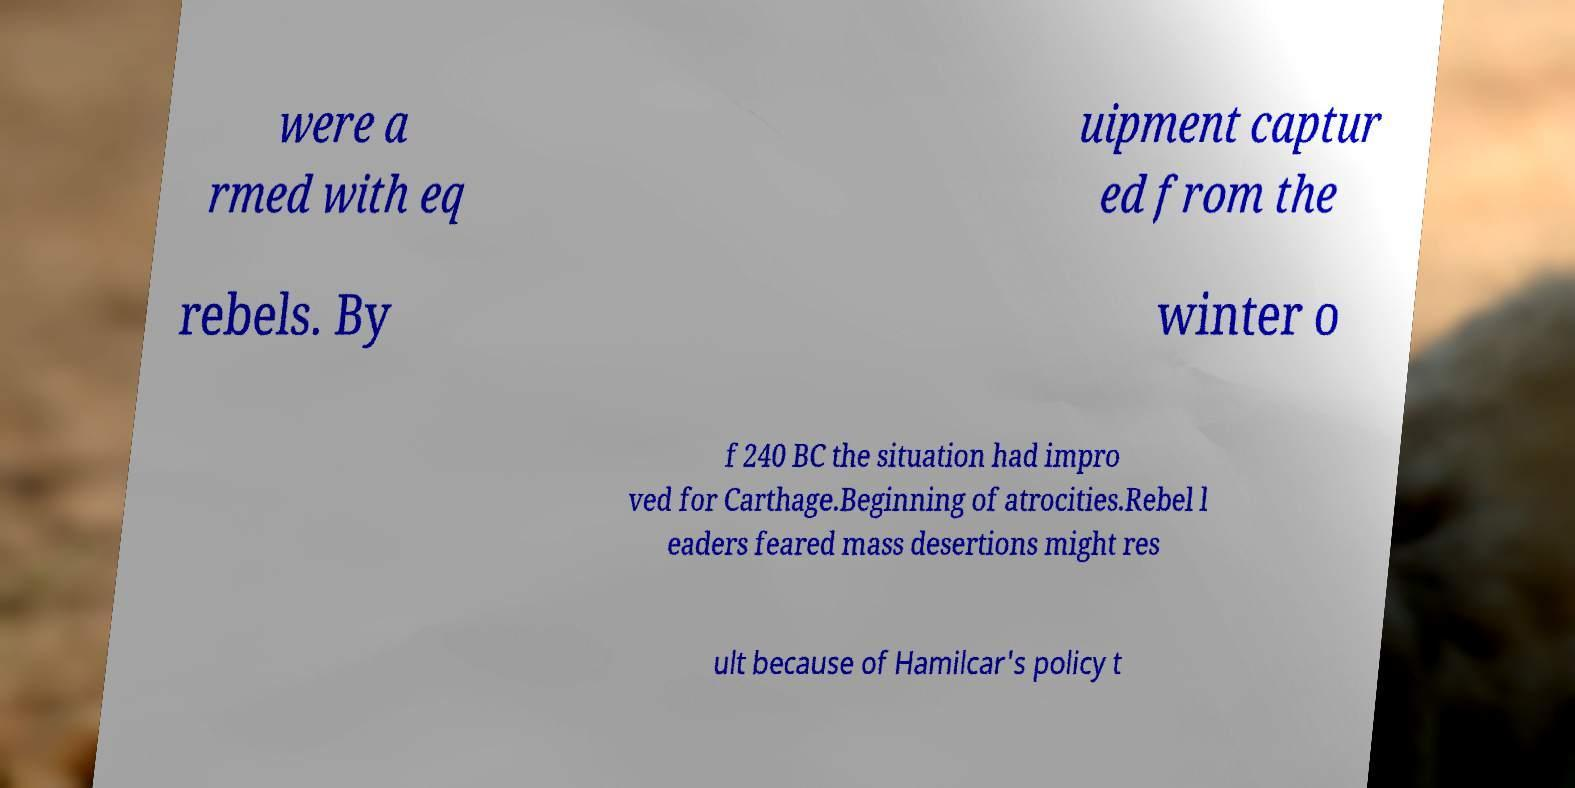There's text embedded in this image that I need extracted. Can you transcribe it verbatim? were a rmed with eq uipment captur ed from the rebels. By winter o f 240 BC the situation had impro ved for Carthage.Beginning of atrocities.Rebel l eaders feared mass desertions might res ult because of Hamilcar's policy t 